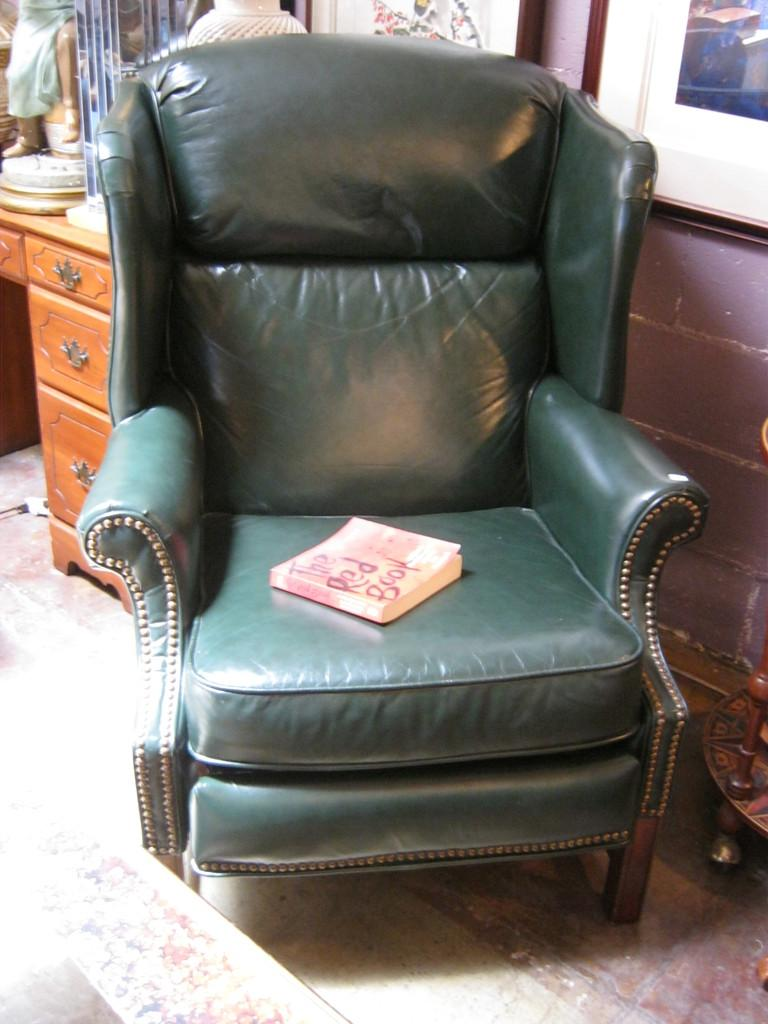What color is the sofa in the image? The sofa in the image is green. What is placed on the sofa? There is a book on the sofa. What furniture piece is present in the image besides the sofa and table? There is a desk in the image. What items can be seen on the desk? There is a vase and a statue on the desk. What is the color of the table in the image? The table in the image is brown. What type of sweater is the person wearing while sitting on the throne in the image? There is no person wearing a sweater or sitting on a throne in the image. What thought is the statue having while looking at the vase on the desk in the image? The statue is an inanimate object and does not have thoughts. 